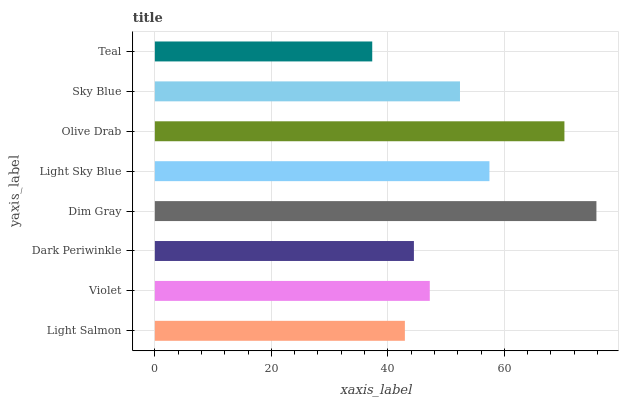Is Teal the minimum?
Answer yes or no. Yes. Is Dim Gray the maximum?
Answer yes or no. Yes. Is Violet the minimum?
Answer yes or no. No. Is Violet the maximum?
Answer yes or no. No. Is Violet greater than Light Salmon?
Answer yes or no. Yes. Is Light Salmon less than Violet?
Answer yes or no. Yes. Is Light Salmon greater than Violet?
Answer yes or no. No. Is Violet less than Light Salmon?
Answer yes or no. No. Is Sky Blue the high median?
Answer yes or no. Yes. Is Violet the low median?
Answer yes or no. Yes. Is Dim Gray the high median?
Answer yes or no. No. Is Teal the low median?
Answer yes or no. No. 